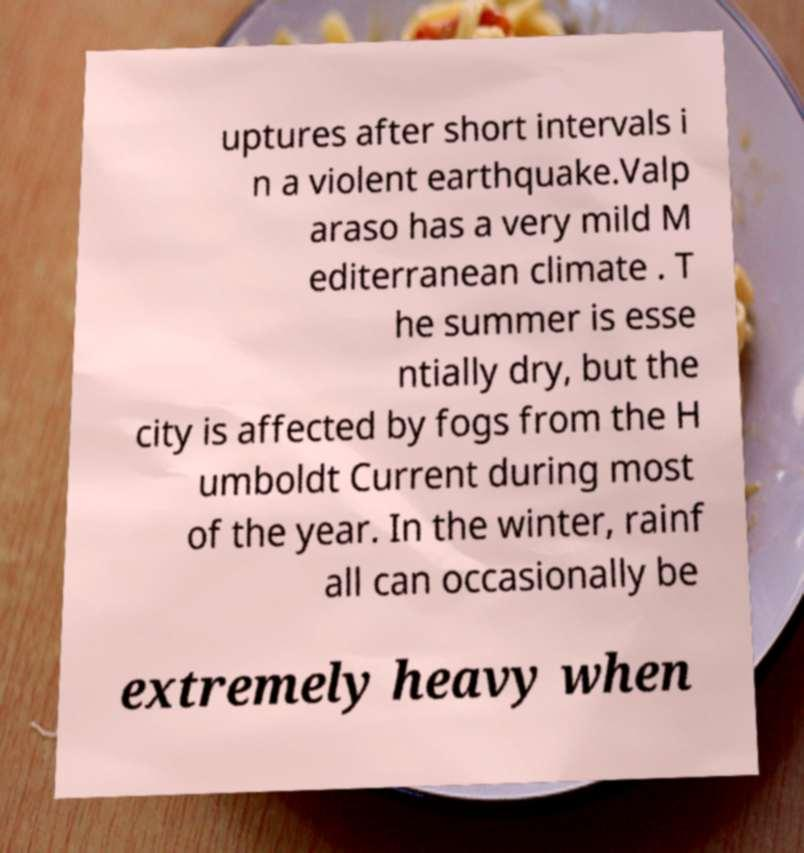What messages or text are displayed in this image? I need them in a readable, typed format. uptures after short intervals i n a violent earthquake.Valp araso has a very mild M editerranean climate . T he summer is esse ntially dry, but the city is affected by fogs from the H umboldt Current during most of the year. In the winter, rainf all can occasionally be extremely heavy when 